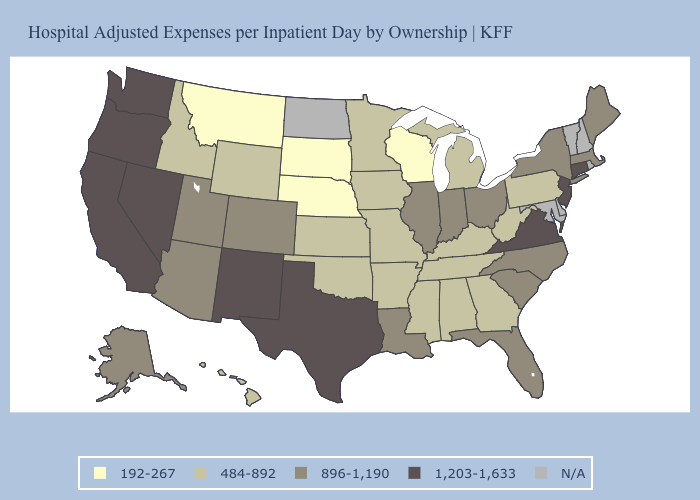Which states hav the highest value in the MidWest?
Write a very short answer. Illinois, Indiana, Ohio. Name the states that have a value in the range 192-267?
Be succinct. Montana, Nebraska, South Dakota, Wisconsin. What is the value of Texas?
Write a very short answer. 1,203-1,633. What is the lowest value in states that border South Dakota?
Answer briefly. 192-267. What is the value of Utah?
Keep it brief. 896-1,190. What is the lowest value in states that border Louisiana?
Write a very short answer. 484-892. How many symbols are there in the legend?
Quick response, please. 5. Does Connecticut have the highest value in the Northeast?
Short answer required. Yes. Among the states that border Georgia , does Alabama have the lowest value?
Concise answer only. Yes. What is the lowest value in states that border Missouri?
Short answer required. 192-267. What is the value of Pennsylvania?
Concise answer only. 484-892. Name the states that have a value in the range 1,203-1,633?
Answer briefly. California, Connecticut, Nevada, New Jersey, New Mexico, Oregon, Texas, Virginia, Washington. What is the value of Tennessee?
Give a very brief answer. 484-892. 